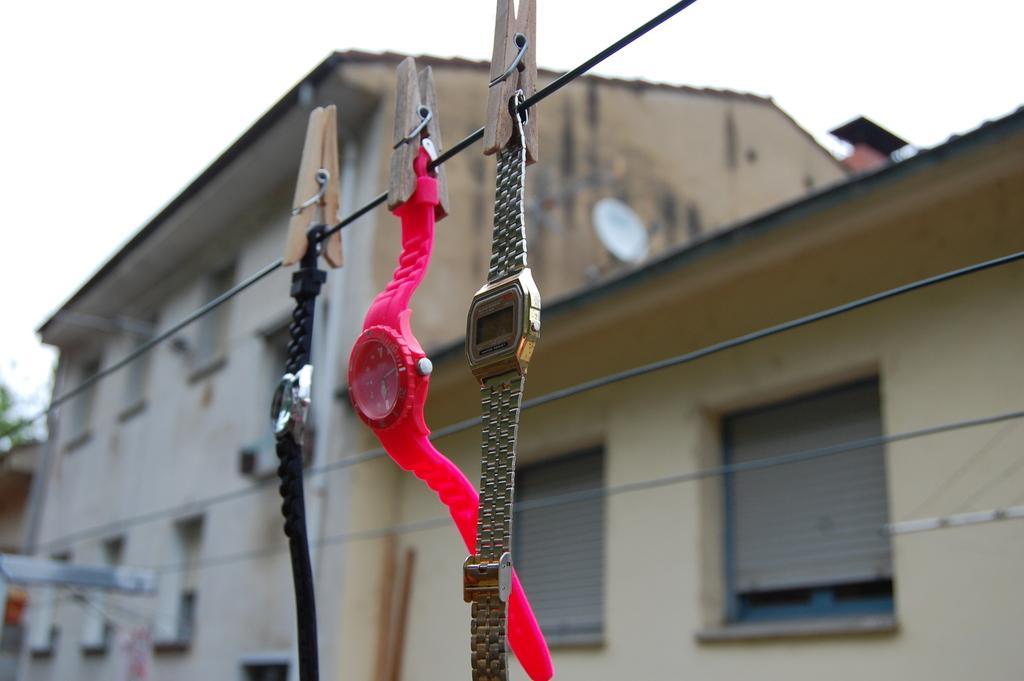In one or two sentences, can you explain what this image depicts? In the middle of the image we can see some ropes, on the ropes we can see three watches and clips. Behind the watches we can see some buildings. At the top of the image we can see the sky. 